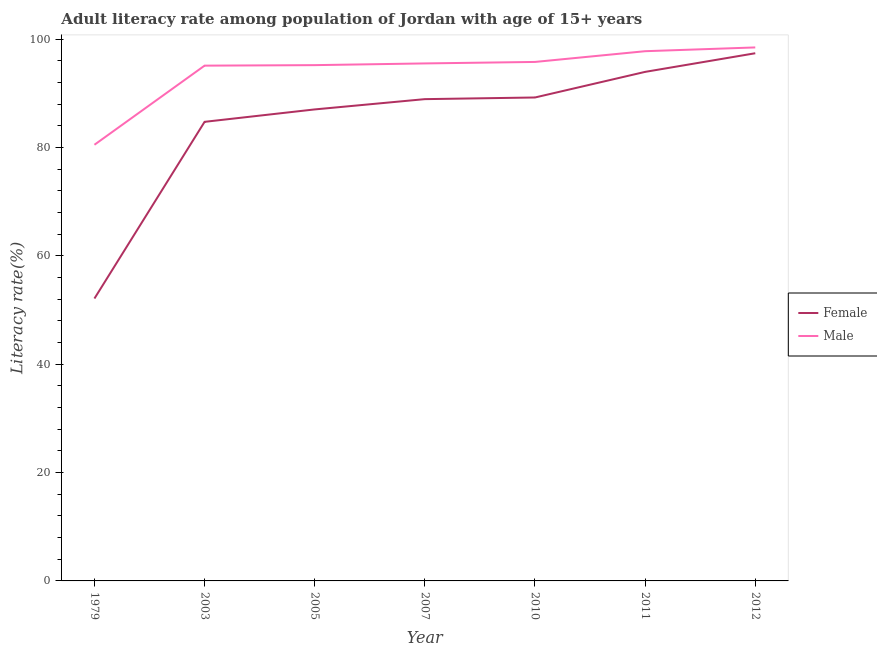What is the male adult literacy rate in 2007?
Give a very brief answer. 95.49. Across all years, what is the maximum male adult literacy rate?
Make the answer very short. 98.44. Across all years, what is the minimum female adult literacy rate?
Offer a very short reply. 52.11. In which year was the female adult literacy rate minimum?
Your answer should be very brief. 1979. What is the total male adult literacy rate in the graph?
Make the answer very short. 658.2. What is the difference between the male adult literacy rate in 2005 and that in 2012?
Your response must be concise. -3.27. What is the difference between the male adult literacy rate in 2005 and the female adult literacy rate in 2007?
Your response must be concise. 6.27. What is the average female adult literacy rate per year?
Make the answer very short. 84.75. In the year 2005, what is the difference between the female adult literacy rate and male adult literacy rate?
Your answer should be compact. -8.17. What is the ratio of the female adult literacy rate in 2010 to that in 2012?
Your answer should be compact. 0.92. Is the female adult literacy rate in 1979 less than that in 2003?
Ensure brevity in your answer.  Yes. What is the difference between the highest and the second highest female adult literacy rate?
Give a very brief answer. 3.44. What is the difference between the highest and the lowest male adult literacy rate?
Make the answer very short. 17.96. In how many years, is the female adult literacy rate greater than the average female adult literacy rate taken over all years?
Give a very brief answer. 5. Does the graph contain any zero values?
Give a very brief answer. No. Where does the legend appear in the graph?
Your response must be concise. Center right. How many legend labels are there?
Ensure brevity in your answer.  2. What is the title of the graph?
Offer a very short reply. Adult literacy rate among population of Jordan with age of 15+ years. What is the label or title of the X-axis?
Offer a very short reply. Year. What is the label or title of the Y-axis?
Provide a short and direct response. Literacy rate(%). What is the Literacy rate(%) of Female in 1979?
Keep it short and to the point. 52.11. What is the Literacy rate(%) in Male in 1979?
Offer a very short reply. 80.48. What is the Literacy rate(%) in Female in 2003?
Your answer should be very brief. 84.71. What is the Literacy rate(%) of Male in 2003?
Offer a terse response. 95.08. What is the Literacy rate(%) in Female in 2005?
Your answer should be very brief. 87.01. What is the Literacy rate(%) in Male in 2005?
Your answer should be compact. 95.18. What is the Literacy rate(%) of Female in 2007?
Provide a succinct answer. 88.9. What is the Literacy rate(%) of Male in 2007?
Offer a very short reply. 95.49. What is the Literacy rate(%) in Female in 2010?
Give a very brief answer. 89.21. What is the Literacy rate(%) in Male in 2010?
Keep it short and to the point. 95.77. What is the Literacy rate(%) in Female in 2011?
Ensure brevity in your answer.  93.93. What is the Literacy rate(%) in Male in 2011?
Your answer should be very brief. 97.75. What is the Literacy rate(%) in Female in 2012?
Make the answer very short. 97.37. What is the Literacy rate(%) of Male in 2012?
Your response must be concise. 98.44. Across all years, what is the maximum Literacy rate(%) of Female?
Ensure brevity in your answer.  97.37. Across all years, what is the maximum Literacy rate(%) of Male?
Your response must be concise. 98.44. Across all years, what is the minimum Literacy rate(%) of Female?
Give a very brief answer. 52.11. Across all years, what is the minimum Literacy rate(%) of Male?
Your answer should be compact. 80.48. What is the total Literacy rate(%) in Female in the graph?
Provide a short and direct response. 593.25. What is the total Literacy rate(%) in Male in the graph?
Give a very brief answer. 658.2. What is the difference between the Literacy rate(%) of Female in 1979 and that in 2003?
Offer a very short reply. -32.6. What is the difference between the Literacy rate(%) of Male in 1979 and that in 2003?
Your answer should be very brief. -14.6. What is the difference between the Literacy rate(%) of Female in 1979 and that in 2005?
Provide a succinct answer. -34.9. What is the difference between the Literacy rate(%) of Male in 1979 and that in 2005?
Offer a terse response. -14.69. What is the difference between the Literacy rate(%) of Female in 1979 and that in 2007?
Make the answer very short. -36.79. What is the difference between the Literacy rate(%) of Male in 1979 and that in 2007?
Offer a very short reply. -15.01. What is the difference between the Literacy rate(%) of Female in 1979 and that in 2010?
Your response must be concise. -37.1. What is the difference between the Literacy rate(%) in Male in 1979 and that in 2010?
Your answer should be very brief. -15.28. What is the difference between the Literacy rate(%) of Female in 1979 and that in 2011?
Your answer should be compact. -41.82. What is the difference between the Literacy rate(%) of Male in 1979 and that in 2011?
Give a very brief answer. -17.27. What is the difference between the Literacy rate(%) in Female in 1979 and that in 2012?
Offer a terse response. -45.26. What is the difference between the Literacy rate(%) of Male in 1979 and that in 2012?
Your response must be concise. -17.96. What is the difference between the Literacy rate(%) of Female in 2003 and that in 2005?
Your response must be concise. -2.29. What is the difference between the Literacy rate(%) in Male in 2003 and that in 2005?
Ensure brevity in your answer.  -0.09. What is the difference between the Literacy rate(%) in Female in 2003 and that in 2007?
Your answer should be compact. -4.19. What is the difference between the Literacy rate(%) of Male in 2003 and that in 2007?
Your answer should be compact. -0.41. What is the difference between the Literacy rate(%) in Female in 2003 and that in 2010?
Offer a terse response. -4.49. What is the difference between the Literacy rate(%) in Male in 2003 and that in 2010?
Ensure brevity in your answer.  -0.68. What is the difference between the Literacy rate(%) in Female in 2003 and that in 2011?
Keep it short and to the point. -9.22. What is the difference between the Literacy rate(%) of Male in 2003 and that in 2011?
Your answer should be very brief. -2.66. What is the difference between the Literacy rate(%) of Female in 2003 and that in 2012?
Provide a succinct answer. -12.66. What is the difference between the Literacy rate(%) of Male in 2003 and that in 2012?
Offer a terse response. -3.36. What is the difference between the Literacy rate(%) in Female in 2005 and that in 2007?
Offer a very short reply. -1.9. What is the difference between the Literacy rate(%) in Male in 2005 and that in 2007?
Your answer should be compact. -0.32. What is the difference between the Literacy rate(%) in Female in 2005 and that in 2010?
Give a very brief answer. -2.2. What is the difference between the Literacy rate(%) in Male in 2005 and that in 2010?
Provide a succinct answer. -0.59. What is the difference between the Literacy rate(%) of Female in 2005 and that in 2011?
Your answer should be compact. -6.93. What is the difference between the Literacy rate(%) of Male in 2005 and that in 2011?
Give a very brief answer. -2.57. What is the difference between the Literacy rate(%) of Female in 2005 and that in 2012?
Give a very brief answer. -10.37. What is the difference between the Literacy rate(%) in Male in 2005 and that in 2012?
Your answer should be compact. -3.27. What is the difference between the Literacy rate(%) in Female in 2007 and that in 2010?
Keep it short and to the point. -0.3. What is the difference between the Literacy rate(%) of Male in 2007 and that in 2010?
Keep it short and to the point. -0.27. What is the difference between the Literacy rate(%) in Female in 2007 and that in 2011?
Offer a very short reply. -5.03. What is the difference between the Literacy rate(%) in Male in 2007 and that in 2011?
Offer a terse response. -2.25. What is the difference between the Literacy rate(%) in Female in 2007 and that in 2012?
Provide a succinct answer. -8.47. What is the difference between the Literacy rate(%) in Male in 2007 and that in 2012?
Give a very brief answer. -2.95. What is the difference between the Literacy rate(%) in Female in 2010 and that in 2011?
Keep it short and to the point. -4.73. What is the difference between the Literacy rate(%) in Male in 2010 and that in 2011?
Offer a terse response. -1.98. What is the difference between the Literacy rate(%) of Female in 2010 and that in 2012?
Offer a terse response. -8.16. What is the difference between the Literacy rate(%) in Male in 2010 and that in 2012?
Your answer should be very brief. -2.68. What is the difference between the Literacy rate(%) in Female in 2011 and that in 2012?
Ensure brevity in your answer.  -3.44. What is the difference between the Literacy rate(%) of Male in 2011 and that in 2012?
Keep it short and to the point. -0.7. What is the difference between the Literacy rate(%) of Female in 1979 and the Literacy rate(%) of Male in 2003?
Offer a very short reply. -42.97. What is the difference between the Literacy rate(%) in Female in 1979 and the Literacy rate(%) in Male in 2005?
Keep it short and to the point. -43.07. What is the difference between the Literacy rate(%) in Female in 1979 and the Literacy rate(%) in Male in 2007?
Provide a succinct answer. -43.38. What is the difference between the Literacy rate(%) in Female in 1979 and the Literacy rate(%) in Male in 2010?
Provide a succinct answer. -43.66. What is the difference between the Literacy rate(%) of Female in 1979 and the Literacy rate(%) of Male in 2011?
Your response must be concise. -45.64. What is the difference between the Literacy rate(%) in Female in 1979 and the Literacy rate(%) in Male in 2012?
Provide a succinct answer. -46.33. What is the difference between the Literacy rate(%) of Female in 2003 and the Literacy rate(%) of Male in 2005?
Your answer should be compact. -10.46. What is the difference between the Literacy rate(%) in Female in 2003 and the Literacy rate(%) in Male in 2007?
Ensure brevity in your answer.  -10.78. What is the difference between the Literacy rate(%) of Female in 2003 and the Literacy rate(%) of Male in 2010?
Offer a terse response. -11.05. What is the difference between the Literacy rate(%) in Female in 2003 and the Literacy rate(%) in Male in 2011?
Offer a very short reply. -13.03. What is the difference between the Literacy rate(%) of Female in 2003 and the Literacy rate(%) of Male in 2012?
Provide a short and direct response. -13.73. What is the difference between the Literacy rate(%) in Female in 2005 and the Literacy rate(%) in Male in 2007?
Your answer should be very brief. -8.49. What is the difference between the Literacy rate(%) of Female in 2005 and the Literacy rate(%) of Male in 2010?
Provide a short and direct response. -8.76. What is the difference between the Literacy rate(%) in Female in 2005 and the Literacy rate(%) in Male in 2011?
Give a very brief answer. -10.74. What is the difference between the Literacy rate(%) of Female in 2005 and the Literacy rate(%) of Male in 2012?
Give a very brief answer. -11.44. What is the difference between the Literacy rate(%) in Female in 2007 and the Literacy rate(%) in Male in 2010?
Ensure brevity in your answer.  -6.86. What is the difference between the Literacy rate(%) in Female in 2007 and the Literacy rate(%) in Male in 2011?
Your answer should be compact. -8.85. What is the difference between the Literacy rate(%) of Female in 2007 and the Literacy rate(%) of Male in 2012?
Offer a very short reply. -9.54. What is the difference between the Literacy rate(%) in Female in 2010 and the Literacy rate(%) in Male in 2011?
Your answer should be very brief. -8.54. What is the difference between the Literacy rate(%) of Female in 2010 and the Literacy rate(%) of Male in 2012?
Give a very brief answer. -9.24. What is the difference between the Literacy rate(%) in Female in 2011 and the Literacy rate(%) in Male in 2012?
Your answer should be very brief. -4.51. What is the average Literacy rate(%) in Female per year?
Your answer should be compact. 84.75. What is the average Literacy rate(%) of Male per year?
Your answer should be compact. 94.03. In the year 1979, what is the difference between the Literacy rate(%) of Female and Literacy rate(%) of Male?
Your response must be concise. -28.37. In the year 2003, what is the difference between the Literacy rate(%) of Female and Literacy rate(%) of Male?
Give a very brief answer. -10.37. In the year 2005, what is the difference between the Literacy rate(%) of Female and Literacy rate(%) of Male?
Ensure brevity in your answer.  -8.17. In the year 2007, what is the difference between the Literacy rate(%) of Female and Literacy rate(%) of Male?
Provide a succinct answer. -6.59. In the year 2010, what is the difference between the Literacy rate(%) in Female and Literacy rate(%) in Male?
Ensure brevity in your answer.  -6.56. In the year 2011, what is the difference between the Literacy rate(%) of Female and Literacy rate(%) of Male?
Give a very brief answer. -3.81. In the year 2012, what is the difference between the Literacy rate(%) of Female and Literacy rate(%) of Male?
Provide a short and direct response. -1.07. What is the ratio of the Literacy rate(%) of Female in 1979 to that in 2003?
Make the answer very short. 0.62. What is the ratio of the Literacy rate(%) of Male in 1979 to that in 2003?
Keep it short and to the point. 0.85. What is the ratio of the Literacy rate(%) of Female in 1979 to that in 2005?
Your answer should be very brief. 0.6. What is the ratio of the Literacy rate(%) of Male in 1979 to that in 2005?
Keep it short and to the point. 0.85. What is the ratio of the Literacy rate(%) in Female in 1979 to that in 2007?
Offer a very short reply. 0.59. What is the ratio of the Literacy rate(%) of Male in 1979 to that in 2007?
Your response must be concise. 0.84. What is the ratio of the Literacy rate(%) in Female in 1979 to that in 2010?
Your answer should be compact. 0.58. What is the ratio of the Literacy rate(%) of Male in 1979 to that in 2010?
Your answer should be very brief. 0.84. What is the ratio of the Literacy rate(%) in Female in 1979 to that in 2011?
Keep it short and to the point. 0.55. What is the ratio of the Literacy rate(%) of Male in 1979 to that in 2011?
Provide a short and direct response. 0.82. What is the ratio of the Literacy rate(%) of Female in 1979 to that in 2012?
Your answer should be compact. 0.54. What is the ratio of the Literacy rate(%) in Male in 1979 to that in 2012?
Your answer should be compact. 0.82. What is the ratio of the Literacy rate(%) of Female in 2003 to that in 2005?
Give a very brief answer. 0.97. What is the ratio of the Literacy rate(%) in Male in 2003 to that in 2005?
Offer a terse response. 1. What is the ratio of the Literacy rate(%) of Female in 2003 to that in 2007?
Your response must be concise. 0.95. What is the ratio of the Literacy rate(%) in Male in 2003 to that in 2007?
Your answer should be compact. 1. What is the ratio of the Literacy rate(%) in Female in 2003 to that in 2010?
Provide a succinct answer. 0.95. What is the ratio of the Literacy rate(%) of Female in 2003 to that in 2011?
Your answer should be very brief. 0.9. What is the ratio of the Literacy rate(%) in Male in 2003 to that in 2011?
Give a very brief answer. 0.97. What is the ratio of the Literacy rate(%) of Female in 2003 to that in 2012?
Ensure brevity in your answer.  0.87. What is the ratio of the Literacy rate(%) in Male in 2003 to that in 2012?
Give a very brief answer. 0.97. What is the ratio of the Literacy rate(%) of Female in 2005 to that in 2007?
Offer a terse response. 0.98. What is the ratio of the Literacy rate(%) of Male in 2005 to that in 2007?
Your response must be concise. 1. What is the ratio of the Literacy rate(%) in Female in 2005 to that in 2010?
Offer a very short reply. 0.98. What is the ratio of the Literacy rate(%) in Female in 2005 to that in 2011?
Make the answer very short. 0.93. What is the ratio of the Literacy rate(%) of Male in 2005 to that in 2011?
Your response must be concise. 0.97. What is the ratio of the Literacy rate(%) of Female in 2005 to that in 2012?
Provide a short and direct response. 0.89. What is the ratio of the Literacy rate(%) of Male in 2005 to that in 2012?
Ensure brevity in your answer.  0.97. What is the ratio of the Literacy rate(%) of Male in 2007 to that in 2010?
Provide a succinct answer. 1. What is the ratio of the Literacy rate(%) in Female in 2007 to that in 2011?
Give a very brief answer. 0.95. What is the ratio of the Literacy rate(%) of Male in 2007 to that in 2011?
Keep it short and to the point. 0.98. What is the ratio of the Literacy rate(%) of Female in 2007 to that in 2012?
Provide a short and direct response. 0.91. What is the ratio of the Literacy rate(%) in Male in 2007 to that in 2012?
Make the answer very short. 0.97. What is the ratio of the Literacy rate(%) of Female in 2010 to that in 2011?
Offer a terse response. 0.95. What is the ratio of the Literacy rate(%) of Male in 2010 to that in 2011?
Your answer should be compact. 0.98. What is the ratio of the Literacy rate(%) in Female in 2010 to that in 2012?
Offer a very short reply. 0.92. What is the ratio of the Literacy rate(%) in Male in 2010 to that in 2012?
Keep it short and to the point. 0.97. What is the ratio of the Literacy rate(%) of Female in 2011 to that in 2012?
Your response must be concise. 0.96. What is the difference between the highest and the second highest Literacy rate(%) of Female?
Your answer should be compact. 3.44. What is the difference between the highest and the second highest Literacy rate(%) in Male?
Offer a terse response. 0.7. What is the difference between the highest and the lowest Literacy rate(%) of Female?
Ensure brevity in your answer.  45.26. What is the difference between the highest and the lowest Literacy rate(%) of Male?
Your response must be concise. 17.96. 